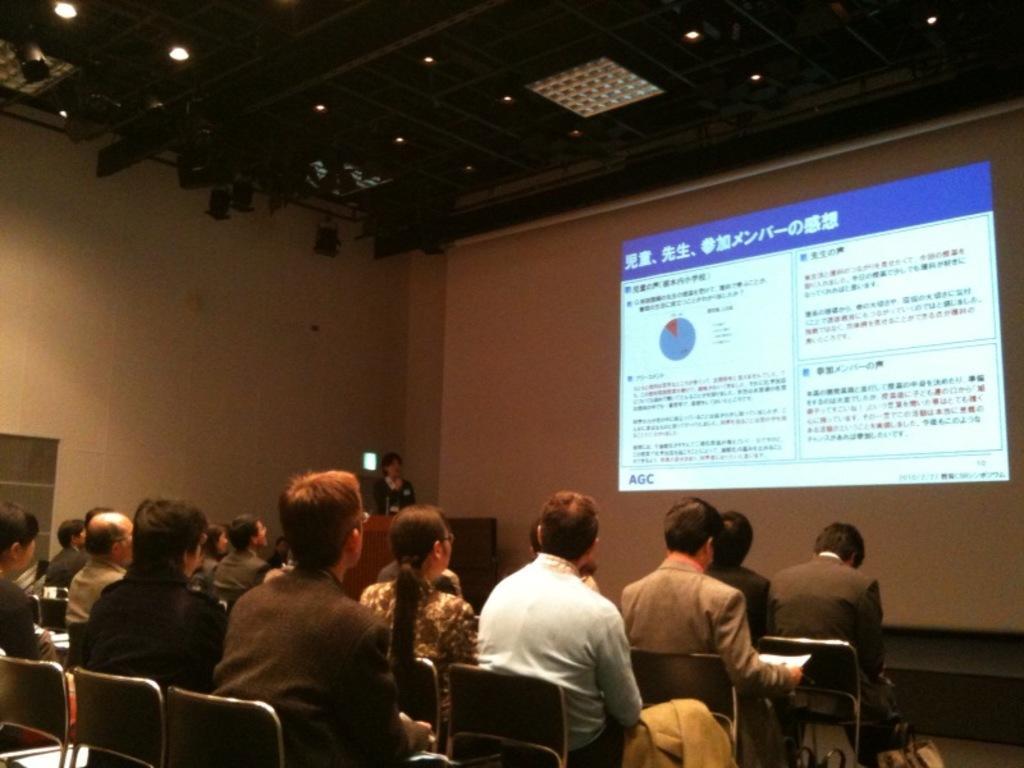In one or two sentences, can you explain what this image depicts? In the image there are people sat on chair and in front there is screen and over the ceiling there are lights. 